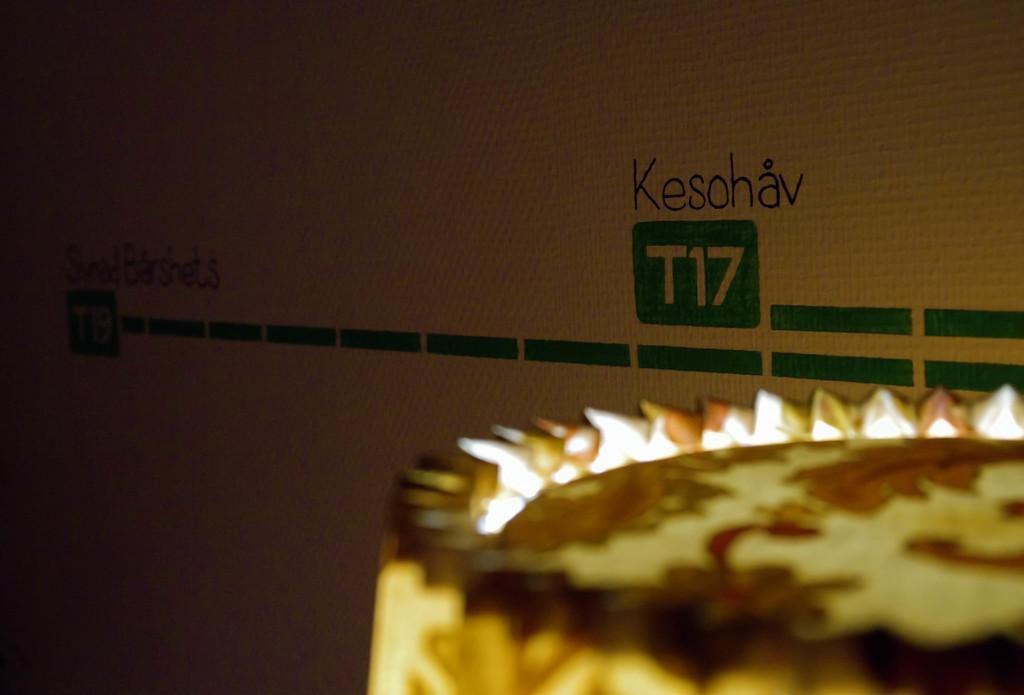What is the main subject in the image? There is an object in the image. What can be seen in the background of the image? There is a wall in the image. What is written on the wall? Text is written on the wall. How many cakes are being flown down the road in the image? There is no road, flight, or cakes present in the image. 